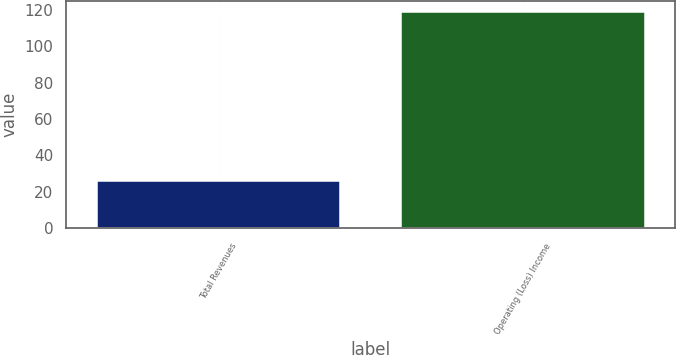Convert chart. <chart><loc_0><loc_0><loc_500><loc_500><bar_chart><fcel>Total Revenues<fcel>Operating (Loss) Income<nl><fcel>26<fcel>119<nl></chart> 